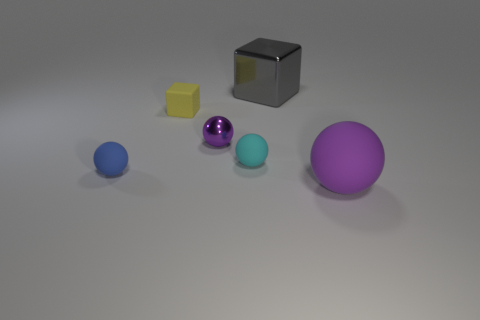There is a rubber thing left of the yellow rubber thing; is it the same shape as the small metallic object?
Your answer should be very brief. Yes. What number of objects are behind the small metal thing and on the right side of the small purple sphere?
Give a very brief answer. 1. What number of other objects are there of the same size as the shiny ball?
Offer a very short reply. 3. Are there an equal number of gray cubes that are behind the yellow matte block and blue matte balls?
Offer a very short reply. Yes. There is a ball that is right of the big shiny object; is its color the same as the metallic object in front of the large gray metal object?
Your answer should be compact. Yes. The object that is both on the right side of the cyan rubber thing and in front of the tiny yellow rubber cube is made of what material?
Offer a very short reply. Rubber. What is the color of the tiny rubber cube?
Your answer should be compact. Yellow. How many other objects are there of the same shape as the big purple object?
Keep it short and to the point. 3. Are there an equal number of cyan objects behind the yellow object and tiny cyan spheres left of the big block?
Your response must be concise. No. What is the big block made of?
Keep it short and to the point. Metal. 